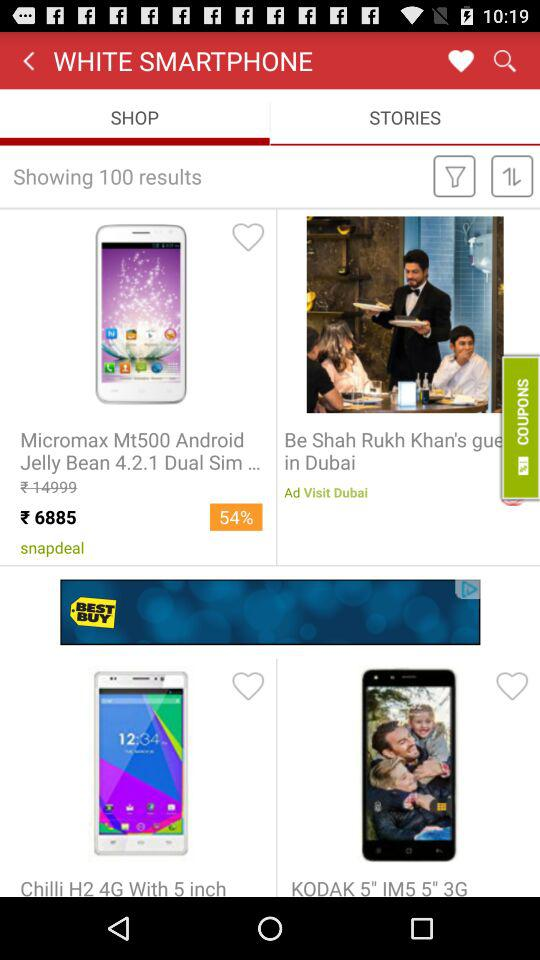How many results have been shown? There are 100 results. 